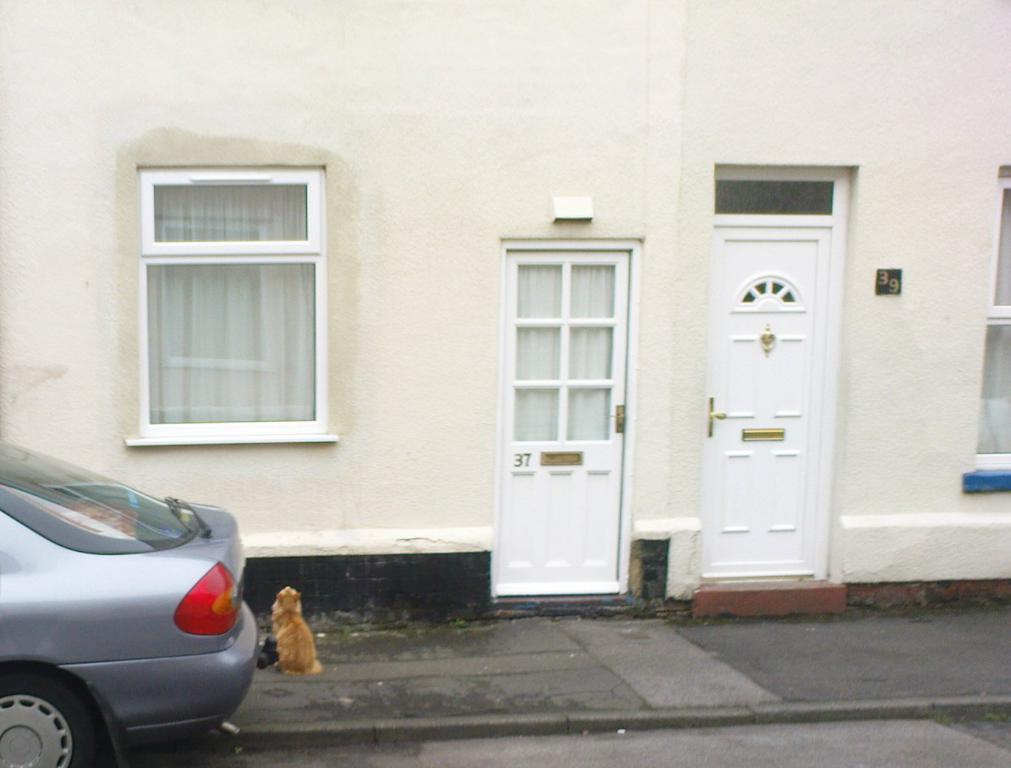What vehicle is located on the left side of the image? There is a car on the left side of the image. What type of structure can be seen in the background of the image? There is a building in the background of the image. What architectural feature is in the middle of the image? There is a window in the middle of the image. What can be used for entering or exiting a room in the image? There is a door in the middle of the image. Where is the crib located in the image? There is no crib present in the image. What type of furniture is in the middle of the image? There is no furniture mentioned in the image; it only includes a car, building, window, and door. 